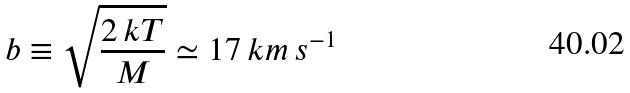Convert formula to latex. <formula><loc_0><loc_0><loc_500><loc_500>b \equiv \sqrt { \frac { 2 \, k T } { M } } \simeq 1 7 \, k m \, s ^ { - 1 }</formula> 